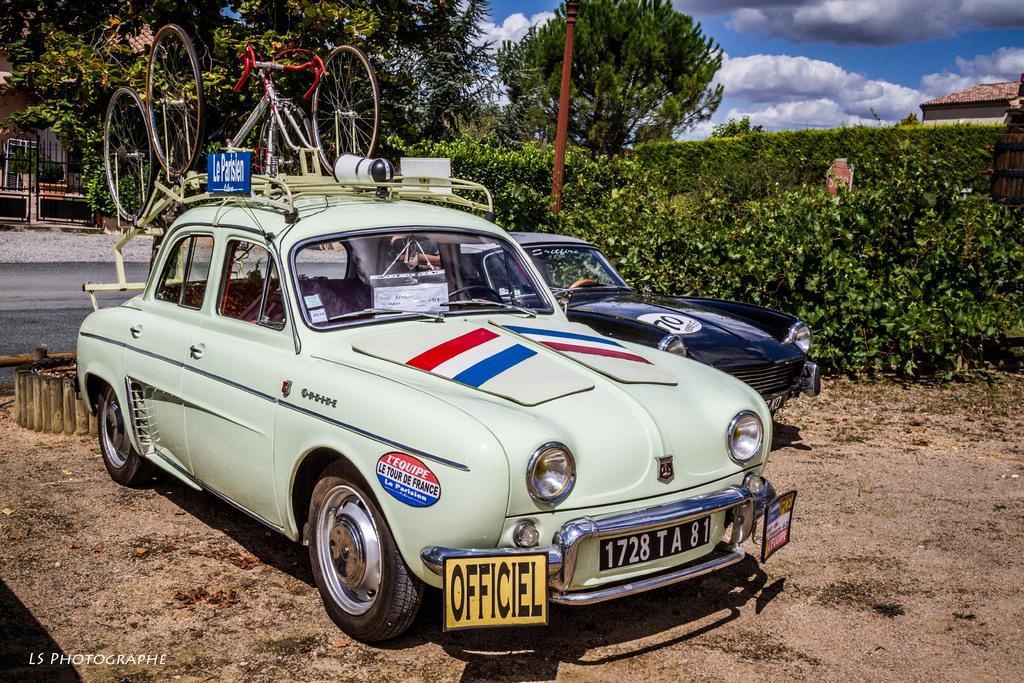Please provide a concise description of this image. We can see cars on the surface and we can see cart on the this car. We can see plants and pole. In the background we can see trees,roof top,gate and sky is cloudy. 